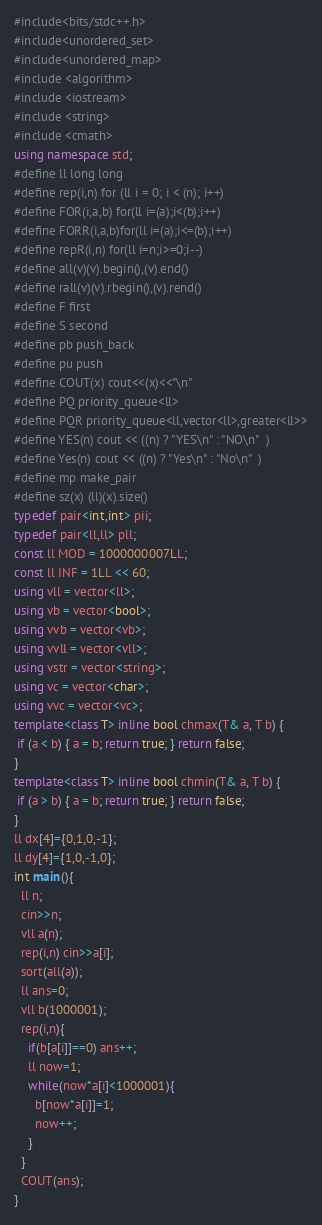<code> <loc_0><loc_0><loc_500><loc_500><_C++_>#include<bits/stdc++.h>
#include<unordered_set>
#include<unordered_map>
#include <algorithm> 
#include <iostream>
#include <string>
#include <cmath>
using namespace std;
#define ll long long
#define rep(i,n) for (ll i = 0; i < (n); i++)
#define FOR(i,a,b) for(ll i=(a);i<(b);i++)
#define FORR(i,a,b)for(ll i=(a);i<=(b);i++)
#define repR(i,n) for(ll i=n;i>=0;i--)
#define all(v)(v).begin(),(v).end()
#define rall(v)(v).rbegin(),(v).rend()
#define F first
#define S second
#define pb push_back
#define pu push
#define COUT(x) cout<<(x)<<"\n"
#define PQ priority_queue<ll>
#define PQR priority_queue<ll,vector<ll>,greater<ll>>
#define YES(n) cout << ((n) ? "YES\n" : "NO\n"  )
#define Yes(n) cout << ((n) ? "Yes\n" : "No\n"  )
#define mp make_pair
#define sz(x) (ll)(x).size()
typedef pair<int,int> pii;
typedef pair<ll,ll> pll;
const ll MOD = 1000000007LL;
const ll INF = 1LL << 60;
using vll = vector<ll>;
using vb = vector<bool>;
using vvb = vector<vb>;
using vvll = vector<vll>;
using vstr = vector<string>;
using vc = vector<char>;
using vvc = vector<vc>;
template<class T> inline bool chmax(T& a, T b) { 
 if (a < b) { a = b; return true; } return false; 
}
template<class T> inline bool chmin(T& a, T b) {
 if (a > b) { a = b; return true; } return false; 
}
ll dx[4]={0,1,0,-1};
ll dy[4]={1,0,-1,0};
int main(){
  ll n;
  cin>>n;
  vll a(n);
  rep(i,n) cin>>a[i];
  sort(all(a));
  ll ans=0;
  vll b(1000001);
  rep(i,n){
    if(b[a[i]]==0) ans++;
    ll now=1;
    while(now*a[i]<1000001){
      b[now*a[i]]=1;
      now++;
    }
  }
  COUT(ans);
}
</code> 